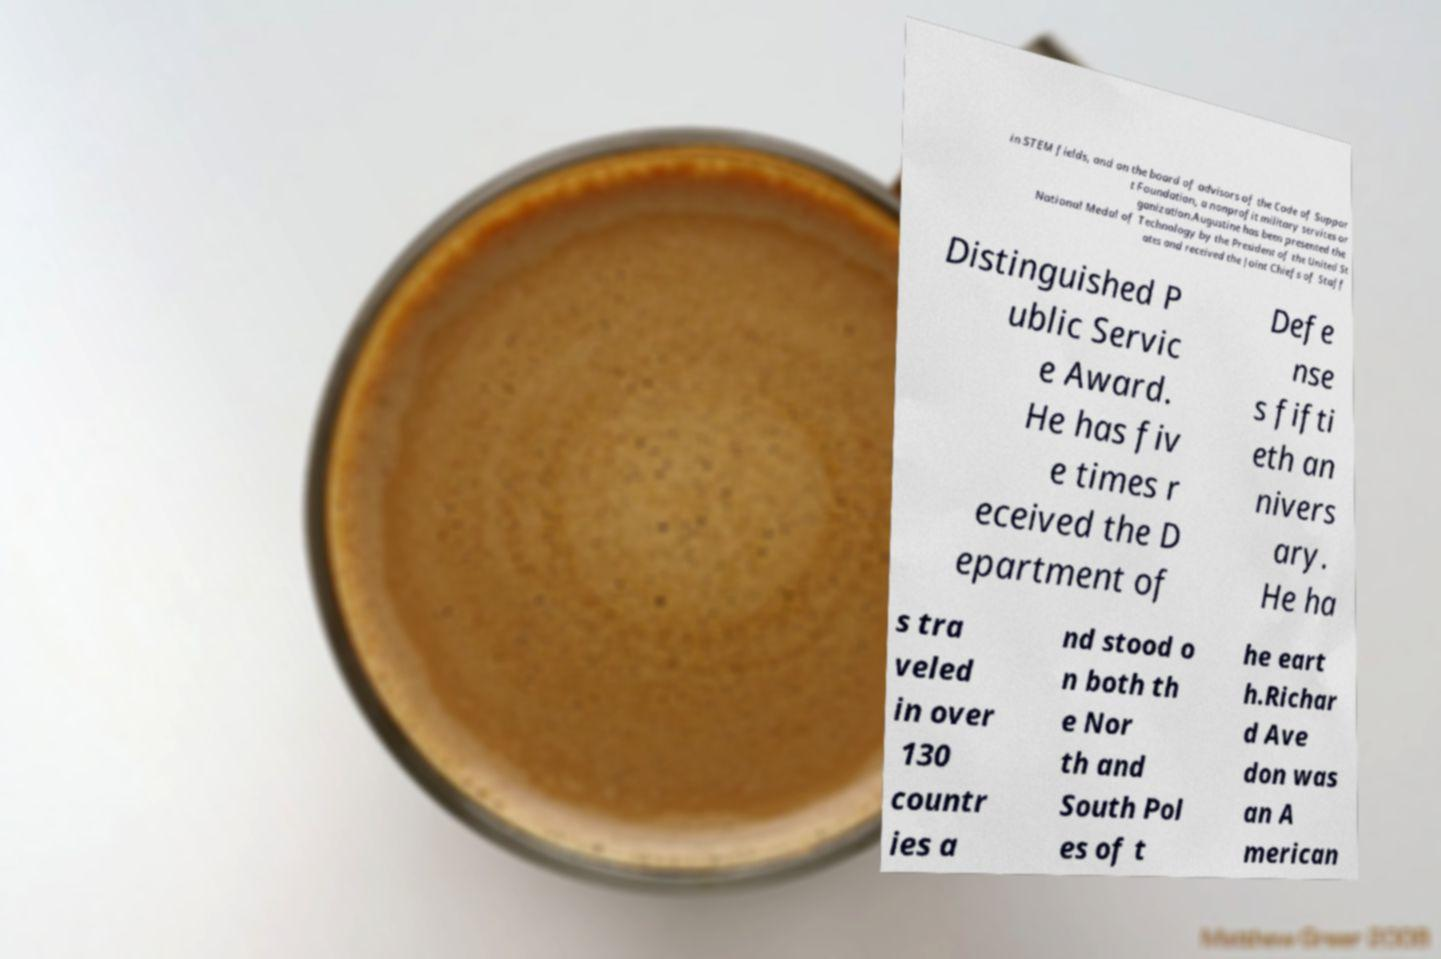For documentation purposes, I need the text within this image transcribed. Could you provide that? in STEM fields, and on the board of advisors of the Code of Suppor t Foundation, a nonprofit military services or ganization.Augustine has been presented the National Medal of Technology by the President of the United St ates and received the Joint Chiefs of Staff Distinguished P ublic Servic e Award. He has fiv e times r eceived the D epartment of Defe nse s fifti eth an nivers ary. He ha s tra veled in over 130 countr ies a nd stood o n both th e Nor th and South Pol es of t he eart h.Richar d Ave don was an A merican 